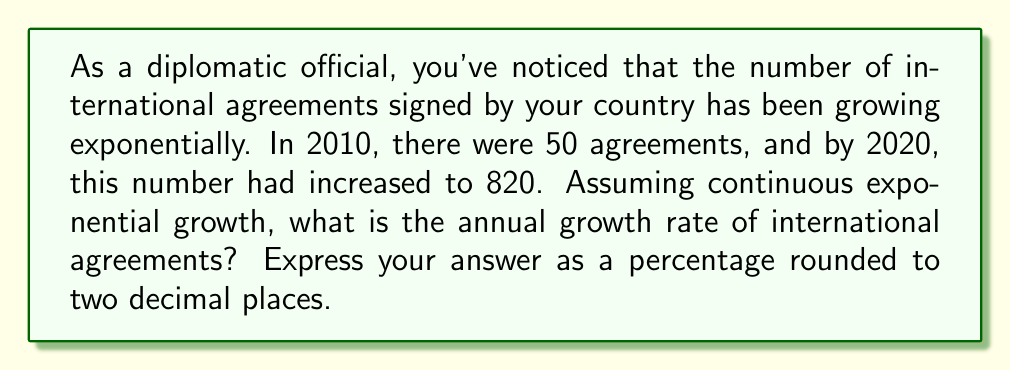Provide a solution to this math problem. To solve this problem, we'll use the exponential growth formula:

$$A = P \cdot e^{rt}$$

Where:
$A$ = Final amount (820 agreements)
$P$ = Initial amount (50 agreements)
$e$ = Euler's number (approximately 2.71828)
$r$ = Annual growth rate (what we're solving for)
$t$ = Time period (10 years)

1) Substitute the known values into the formula:
   $$820 = 50 \cdot e^{10r}$$

2) Divide both sides by 50:
   $$16.4 = e^{10r}$$

3) Take the natural logarithm of both sides:
   $$\ln(16.4) = \ln(e^{10r})$$

4) Simplify the right side using logarithm properties:
   $$\ln(16.4) = 10r$$

5) Solve for $r$:
   $$r = \frac{\ln(16.4)}{10}$$

6) Calculate the value of $r$:
   $$r \approx 0.2796$$

7) Convert to a percentage by multiplying by 100:
   $$27.96\%$$

8) Round to two decimal places:
   $$27.96\%$$
Answer: 27.96% 